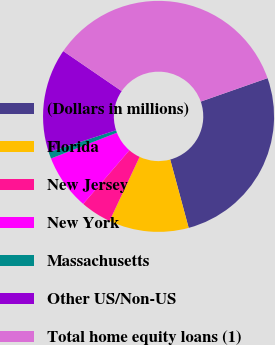<chart> <loc_0><loc_0><loc_500><loc_500><pie_chart><fcel>(Dollars in millions)<fcel>Florida<fcel>New Jersey<fcel>New York<fcel>Massachusetts<fcel>Other US/Non-US<fcel>Total home equity loans (1)<nl><fcel>26.17%<fcel>11.17%<fcel>4.34%<fcel>7.75%<fcel>0.92%<fcel>14.58%<fcel>35.07%<nl></chart> 